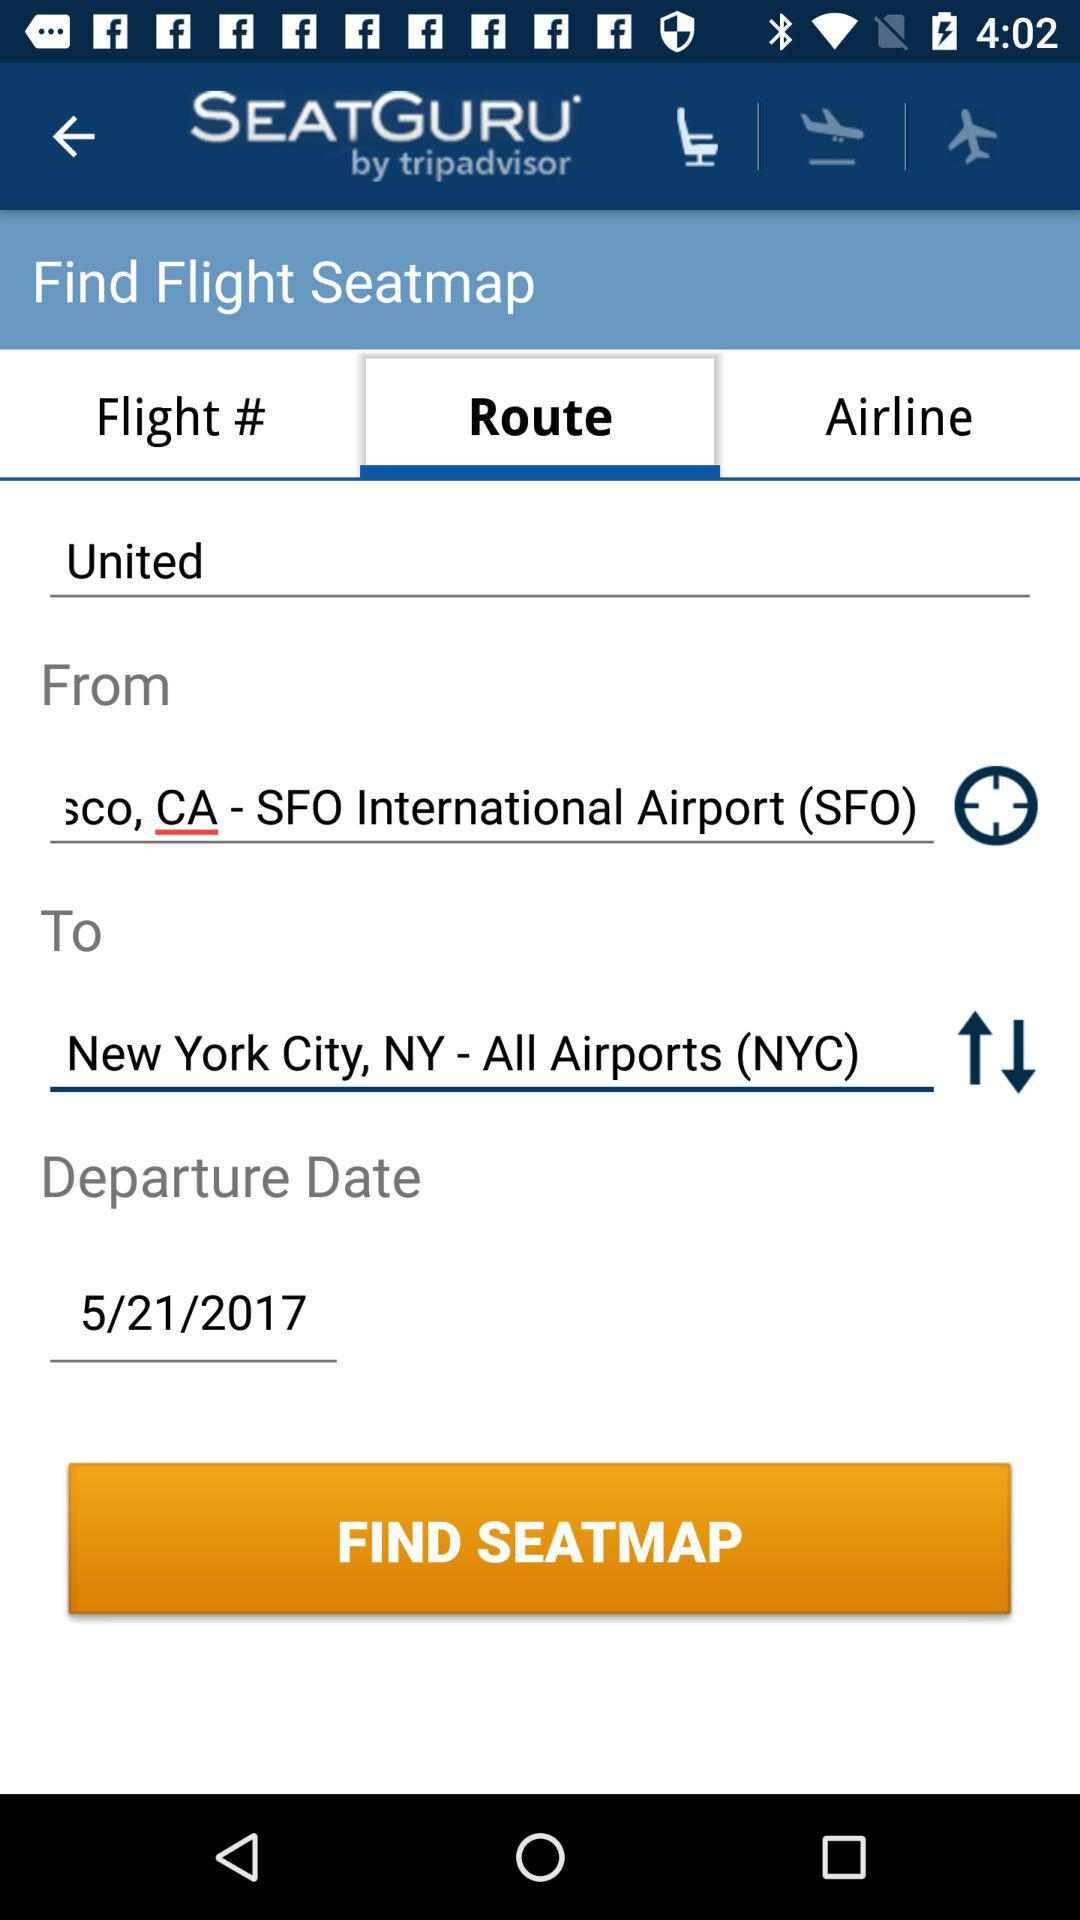From which place Flight departure?
When the provided information is insufficient, respond with <no answer>. <no answer> 